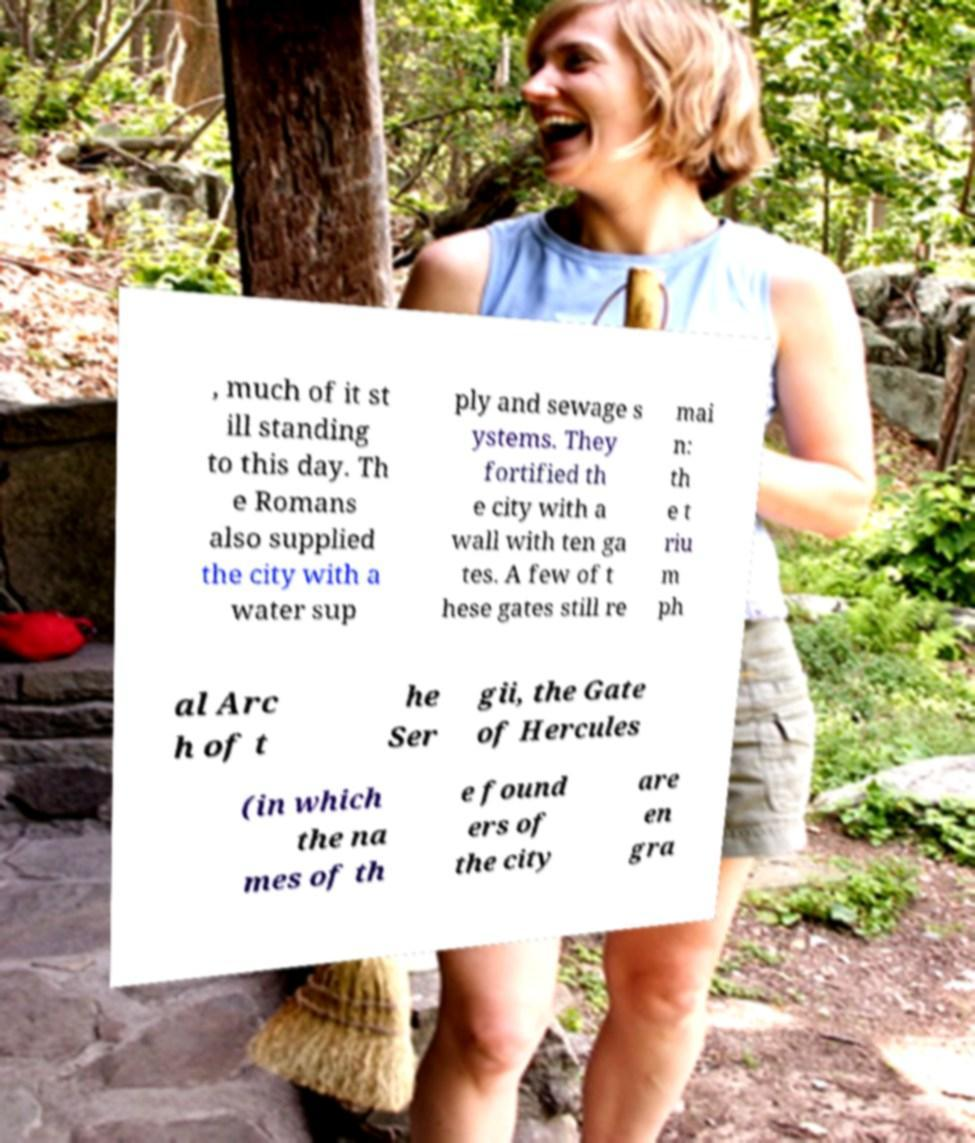Can you accurately transcribe the text from the provided image for me? , much of it st ill standing to this day. Th e Romans also supplied the city with a water sup ply and sewage s ystems. They fortified th e city with a wall with ten ga tes. A few of t hese gates still re mai n: th e t riu m ph al Arc h of t he Ser gii, the Gate of Hercules (in which the na mes of th e found ers of the city are en gra 